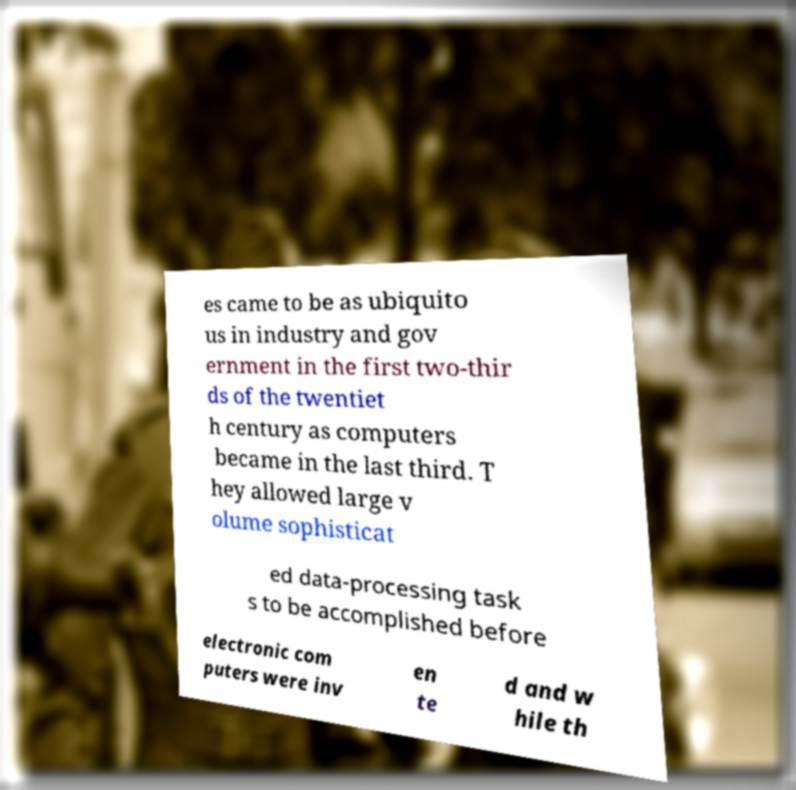For documentation purposes, I need the text within this image transcribed. Could you provide that? es came to be as ubiquito us in industry and gov ernment in the first two-thir ds of the twentiet h century as computers became in the last third. T hey allowed large v olume sophisticat ed data-processing task s to be accomplished before electronic com puters were inv en te d and w hile th 